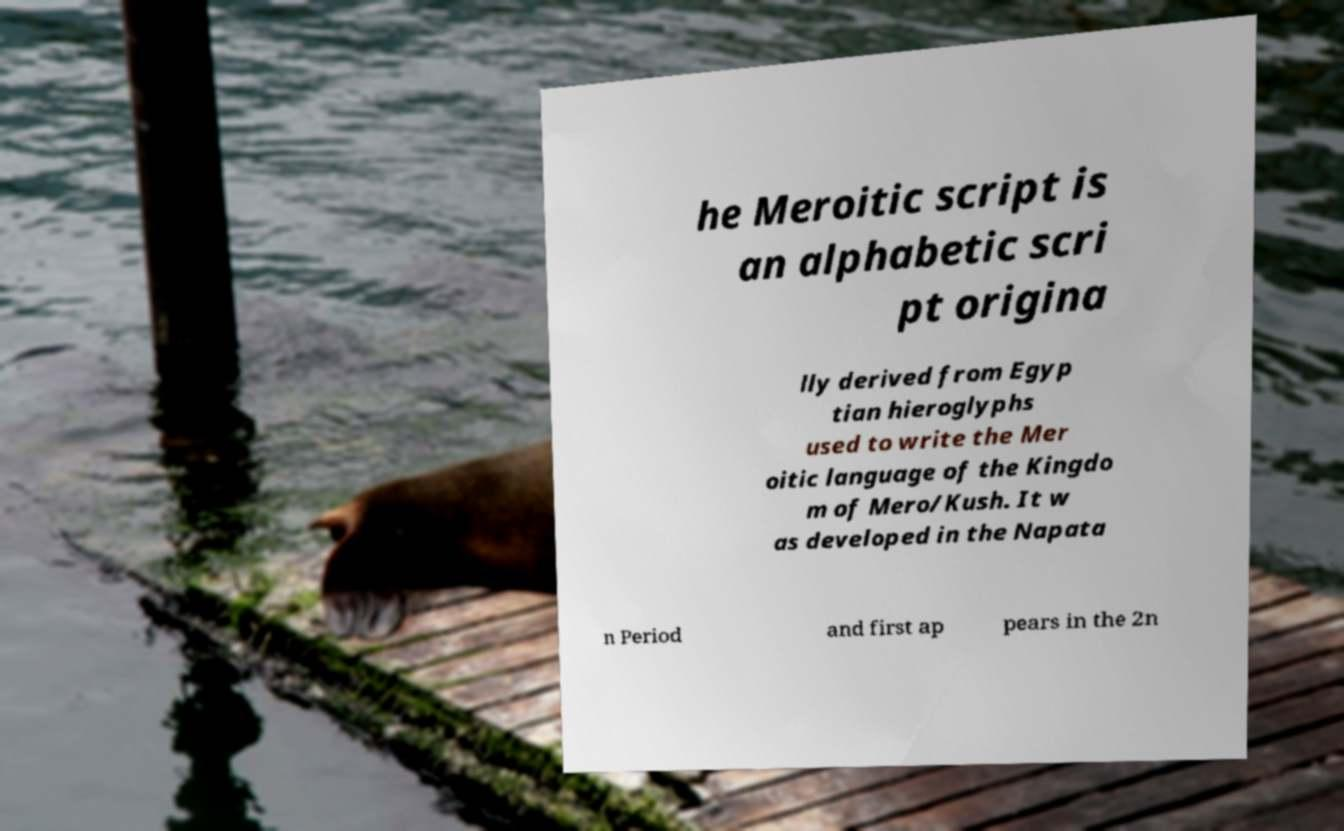What messages or text are displayed in this image? I need them in a readable, typed format. he Meroitic script is an alphabetic scri pt origina lly derived from Egyp tian hieroglyphs used to write the Mer oitic language of the Kingdo m of Mero/Kush. It w as developed in the Napata n Period and first ap pears in the 2n 